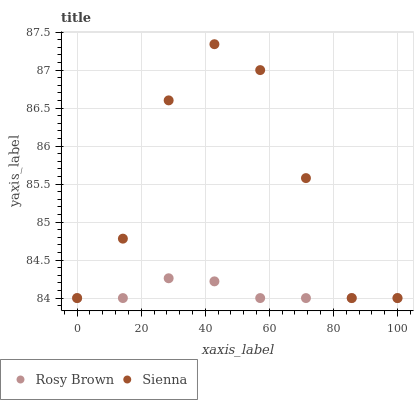Does Rosy Brown have the minimum area under the curve?
Answer yes or no. Yes. Does Sienna have the maximum area under the curve?
Answer yes or no. Yes. Does Rosy Brown have the maximum area under the curve?
Answer yes or no. No. Is Rosy Brown the smoothest?
Answer yes or no. Yes. Is Sienna the roughest?
Answer yes or no. Yes. Is Rosy Brown the roughest?
Answer yes or no. No. Does Sienna have the lowest value?
Answer yes or no. Yes. Does Sienna have the highest value?
Answer yes or no. Yes. Does Rosy Brown have the highest value?
Answer yes or no. No. Does Sienna intersect Rosy Brown?
Answer yes or no. Yes. Is Sienna less than Rosy Brown?
Answer yes or no. No. Is Sienna greater than Rosy Brown?
Answer yes or no. No. 